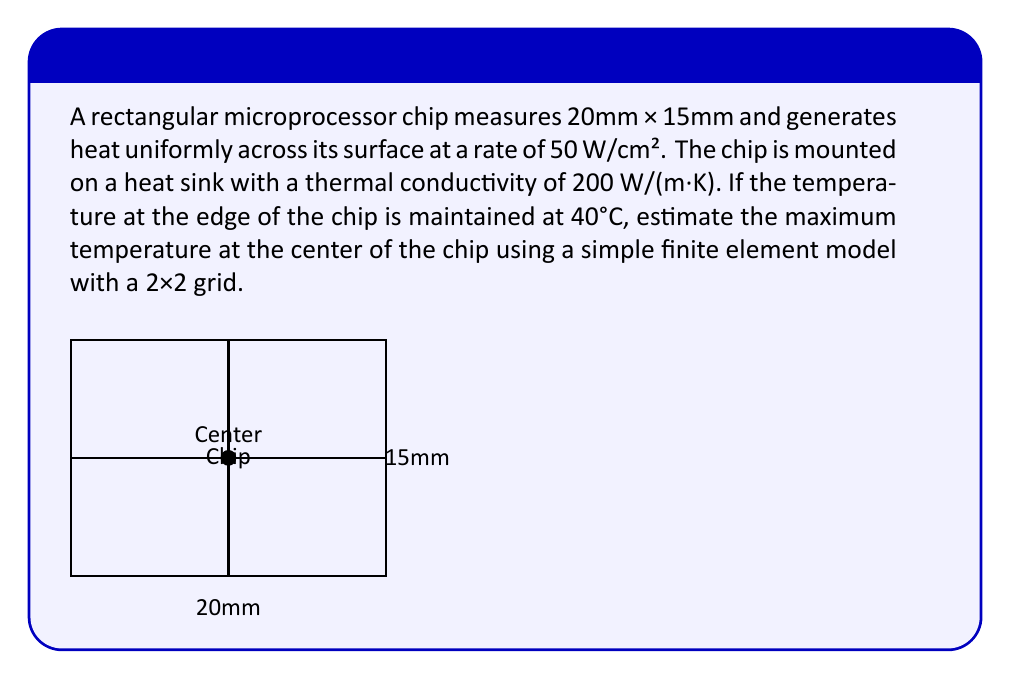Could you help me with this problem? Let's approach this step-by-step:

1) First, we need to set up our finite element grid. With a 2×2 grid, we have 9 nodes: 4 corner nodes, 4 edge midpoint nodes, and 1 center node.

2) Due to symmetry, we only need to solve for the temperature at the center node. The edge midpoint nodes will have temperatures between the center and the corners.

3) The heat equation in steady-state for 2D is:

   $$\frac{\partial^2T}{\partial x^2} + \frac{\partial^2T}{\partial y^2} = -\frac{q}{k}$$

   where $T$ is temperature, $q$ is heat generation per unit volume, and $k$ is thermal conductivity.

4) In finite difference form, this becomes:

   $$\frac{T_{i+1,j} + T_{i-1,j} - 2T_{i,j}}{\Delta x^2} + \frac{T_{i,j+1} + T_{i,j-1} - 2T_{i,j}}{\Delta y^2} = -\frac{q}{k}$$

5) For our case, $\Delta x = 10$ mm and $\Delta y = 7.5$ mm. The heat generation $q$ is 50 W/cm² = 5 × 10⁵ W/m².

6) Substituting these values and solving for the center temperature $T_c$:

   $$\frac{4T_e - 4T_c}{(0.01)^2} + \frac{4T_e - 4T_c}{(0.0075)^2} = -\frac{5 \times 10^5}{200}$$

   where $T_e$ is the edge temperature (40°C).

7) Simplifying:

   $$80000(T_e - T_c) + 142222(T_e - T_c) = -2500$$

   $$222222(T_e - T_c) = -2500$$

   $$T_c - T_e = \frac{2500}{222222} = 0.01125°C$$

8) Therefore, the center temperature is:

   $$T_c = 40°C + 0.01125°C = 40.01125°C$$
Answer: 40.01°C 